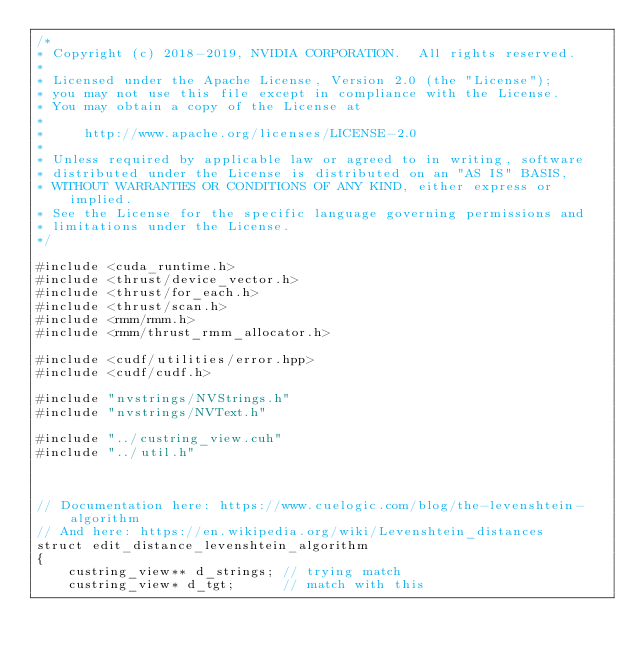Convert code to text. <code><loc_0><loc_0><loc_500><loc_500><_Cuda_>/*
* Copyright (c) 2018-2019, NVIDIA CORPORATION.  All rights reserved.
*
* Licensed under the Apache License, Version 2.0 (the "License");
* you may not use this file except in compliance with the License.
* You may obtain a copy of the License at
*
*     http://www.apache.org/licenses/LICENSE-2.0
*
* Unless required by applicable law or agreed to in writing, software
* distributed under the License is distributed on an "AS IS" BASIS,
* WITHOUT WARRANTIES OR CONDITIONS OF ANY KIND, either express or implied.
* See the License for the specific language governing permissions and
* limitations under the License.
*/

#include <cuda_runtime.h>
#include <thrust/device_vector.h>
#include <thrust/for_each.h>
#include <thrust/scan.h>
#include <rmm/rmm.h>
#include <rmm/thrust_rmm_allocator.h>

#include <cudf/utilities/error.hpp>
#include <cudf/cudf.h>

#include "nvstrings/NVStrings.h"
#include "nvstrings/NVText.h"

#include "../custring_view.cuh"
#include "../util.h"



// Documentation here: https://www.cuelogic.com/blog/the-levenshtein-algorithm
// And here: https://en.wikipedia.org/wiki/Levenshtein_distances
struct edit_distance_levenshtein_algorithm
{
    custring_view** d_strings; // trying match
    custring_view* d_tgt;      // match with this</code> 